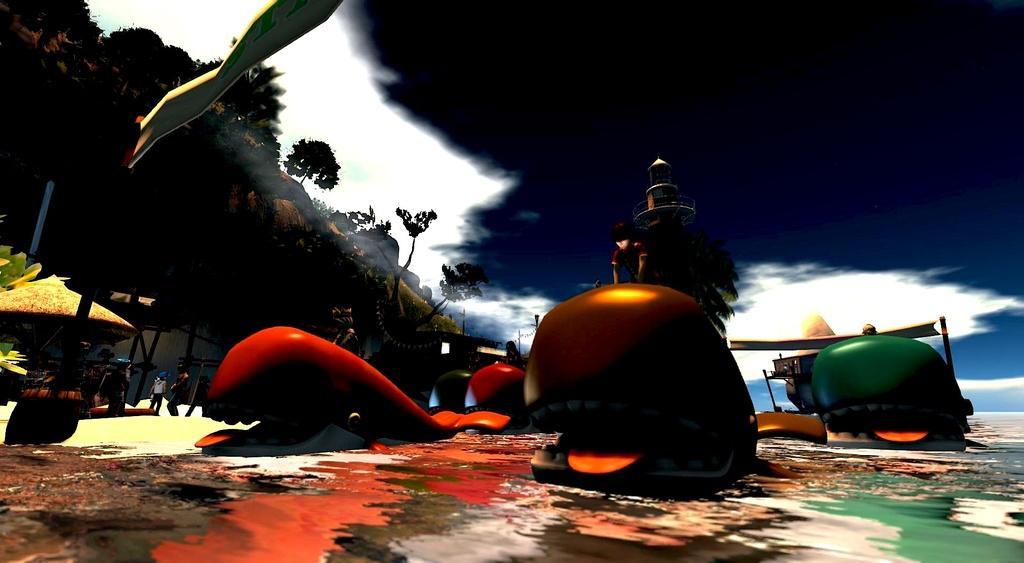In one or two sentences, can you explain what this image depicts? This is an animated image. I can see few people on the fishes, which are in the water. On the left side of the image, I can see a hut, few people and there are trees on a hill. At the top of the image, It looks like a bird. In the background, there is the sky. 